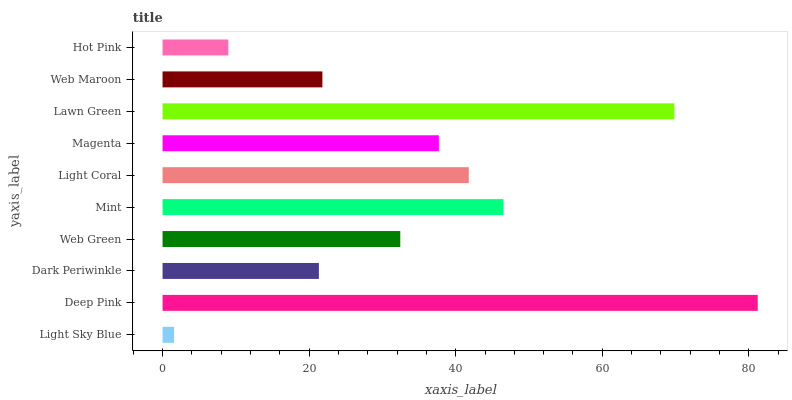Is Light Sky Blue the minimum?
Answer yes or no. Yes. Is Deep Pink the maximum?
Answer yes or no. Yes. Is Dark Periwinkle the minimum?
Answer yes or no. No. Is Dark Periwinkle the maximum?
Answer yes or no. No. Is Deep Pink greater than Dark Periwinkle?
Answer yes or no. Yes. Is Dark Periwinkle less than Deep Pink?
Answer yes or no. Yes. Is Dark Periwinkle greater than Deep Pink?
Answer yes or no. No. Is Deep Pink less than Dark Periwinkle?
Answer yes or no. No. Is Magenta the high median?
Answer yes or no. Yes. Is Web Green the low median?
Answer yes or no. Yes. Is Light Sky Blue the high median?
Answer yes or no. No. Is Dark Periwinkle the low median?
Answer yes or no. No. 